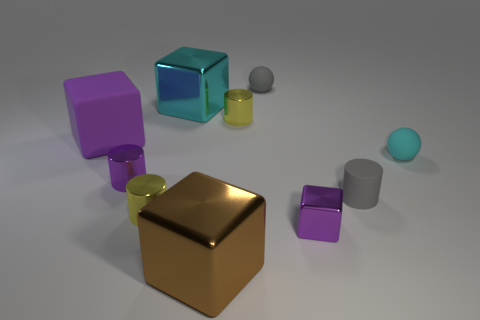What number of objects are large purple balls or small yellow cylinders?
Your answer should be compact. 2. There is a tiny purple metallic thing that is behind the tiny gray cylinder; is there a gray matte thing behind it?
Offer a terse response. Yes. Is the number of balls behind the cyan matte ball greater than the number of purple metal blocks behind the small block?
Keep it short and to the point. Yes. What material is the small block that is the same color as the big rubber thing?
Give a very brief answer. Metal. What number of other matte cubes are the same color as the big rubber cube?
Make the answer very short. 0. Do the tiny metal cylinder that is on the right side of the large brown shiny thing and the shiny block on the left side of the brown metallic cube have the same color?
Keep it short and to the point. No. There is a gray cylinder; are there any small things in front of it?
Offer a terse response. Yes. What is the small cube made of?
Your answer should be very brief. Metal. The large metal object in front of the small block has what shape?
Provide a short and direct response. Cube. What is the size of the sphere that is the same color as the small matte cylinder?
Keep it short and to the point. Small. 